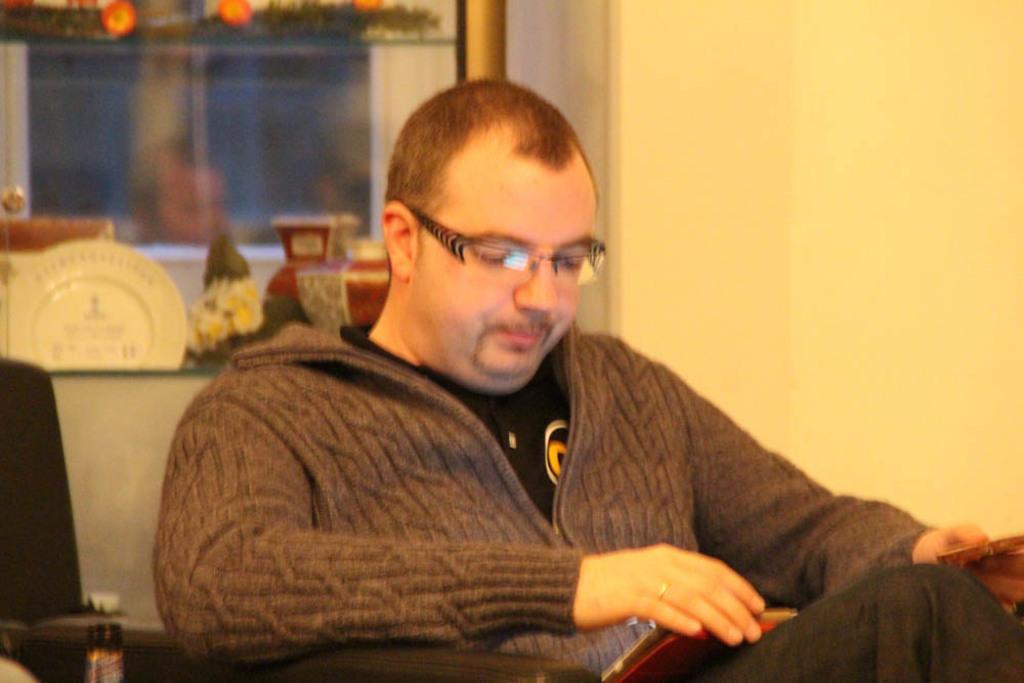Please provide a concise description of this image. In this image we can see a person sitting in a chair holding a book. We can also see a window, wall and a table containing a plate and a flower pot. 